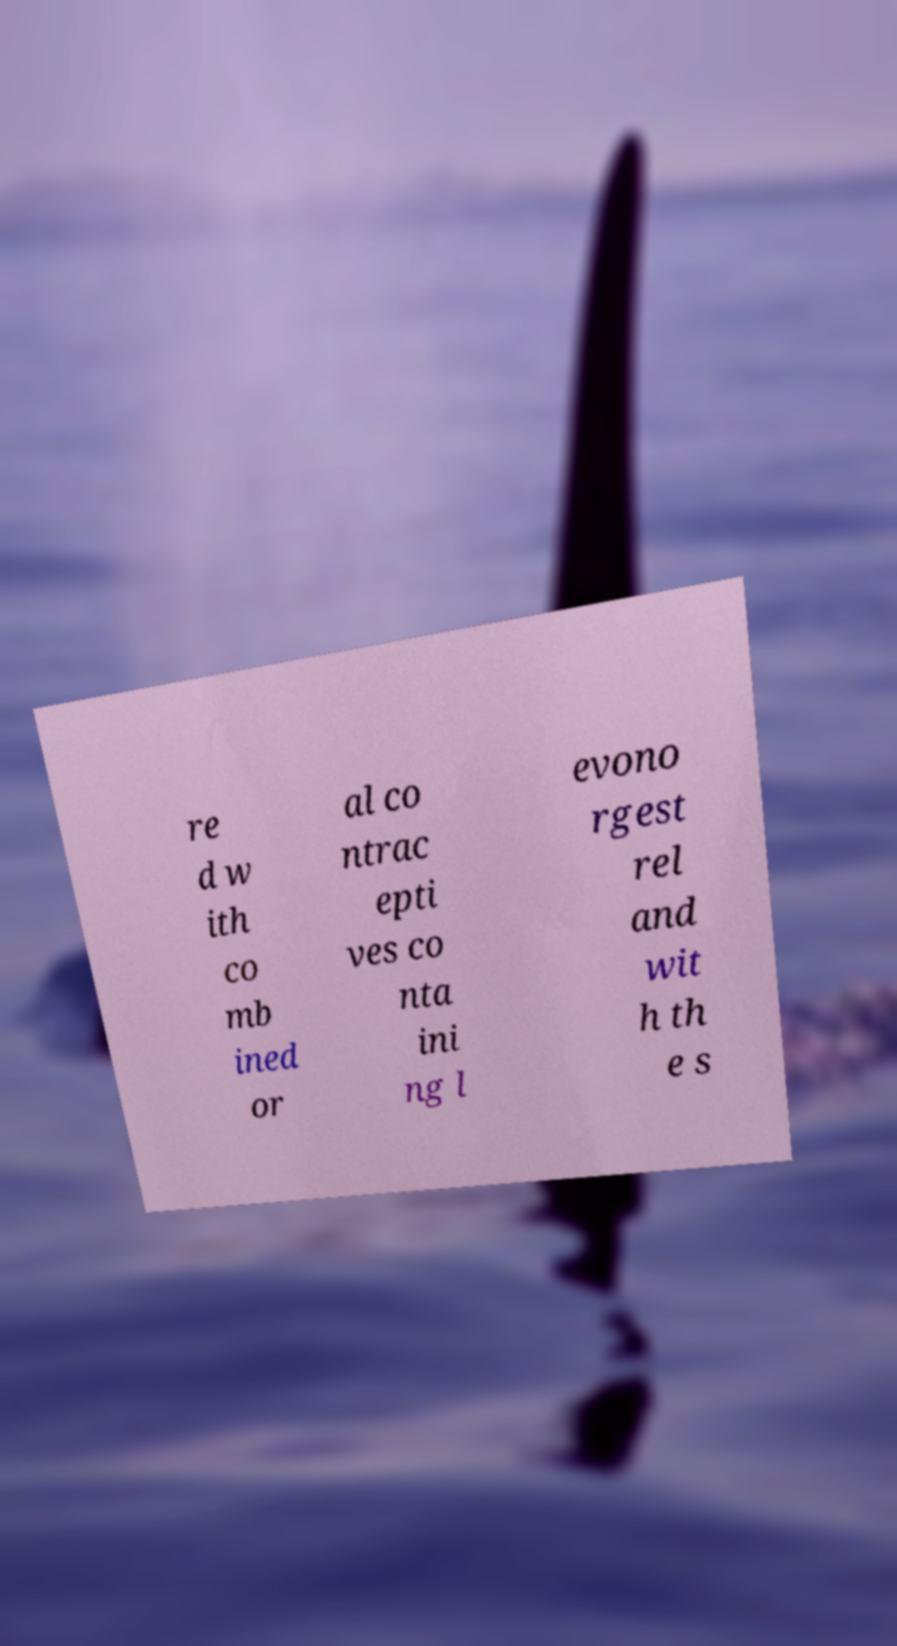Could you extract and type out the text from this image? re d w ith co mb ined or al co ntrac epti ves co nta ini ng l evono rgest rel and wit h th e s 